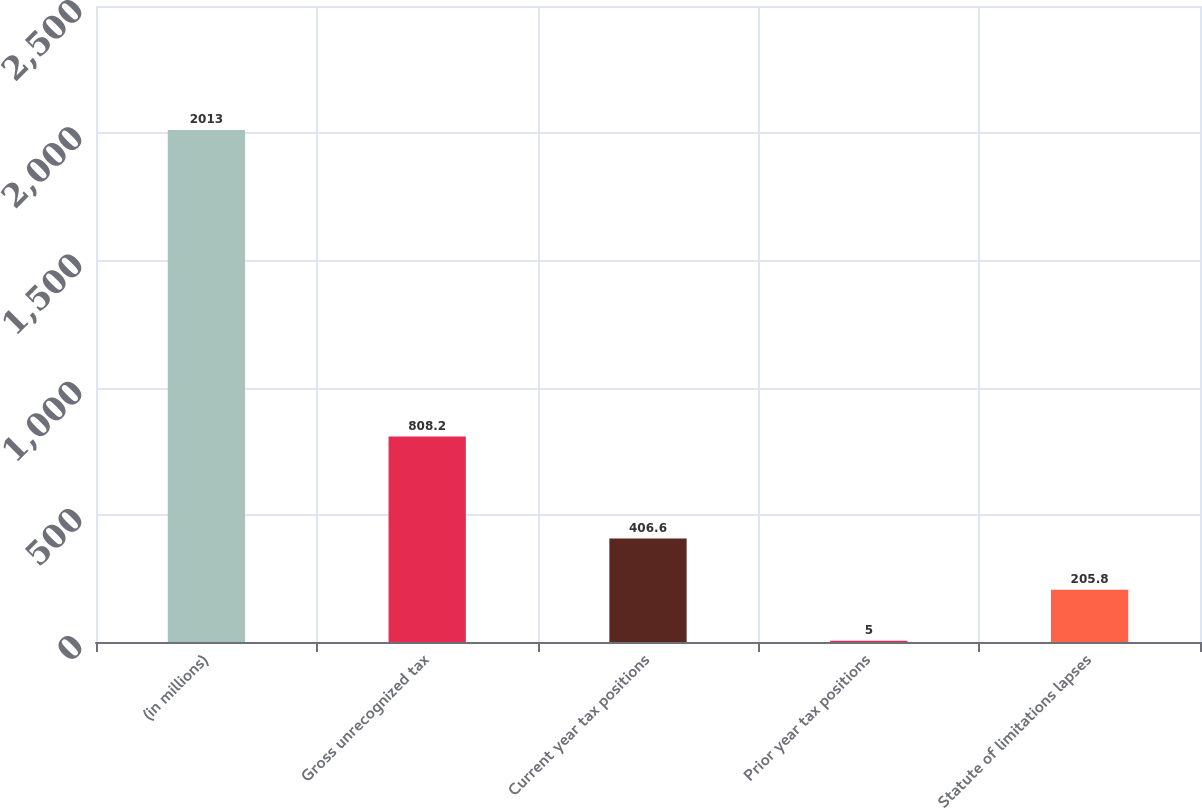Convert chart. <chart><loc_0><loc_0><loc_500><loc_500><bar_chart><fcel>(in millions)<fcel>Gross unrecognized tax<fcel>Current year tax positions<fcel>Prior year tax positions<fcel>Statute of limitations lapses<nl><fcel>2013<fcel>808.2<fcel>406.6<fcel>5<fcel>205.8<nl></chart> 